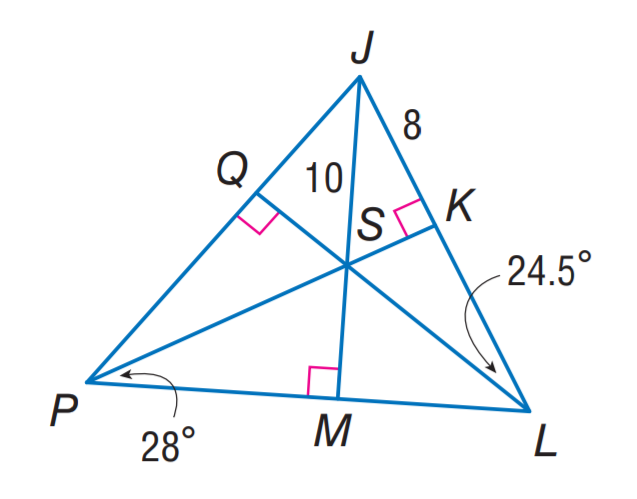Answer the mathemtical geometry problem and directly provide the correct option letter.
Question: Point S is the incenter of \triangle J P L. Find m \angle S J P.
Choices: A: 24.5 B: 37.5 C: 56 D: 75 B 